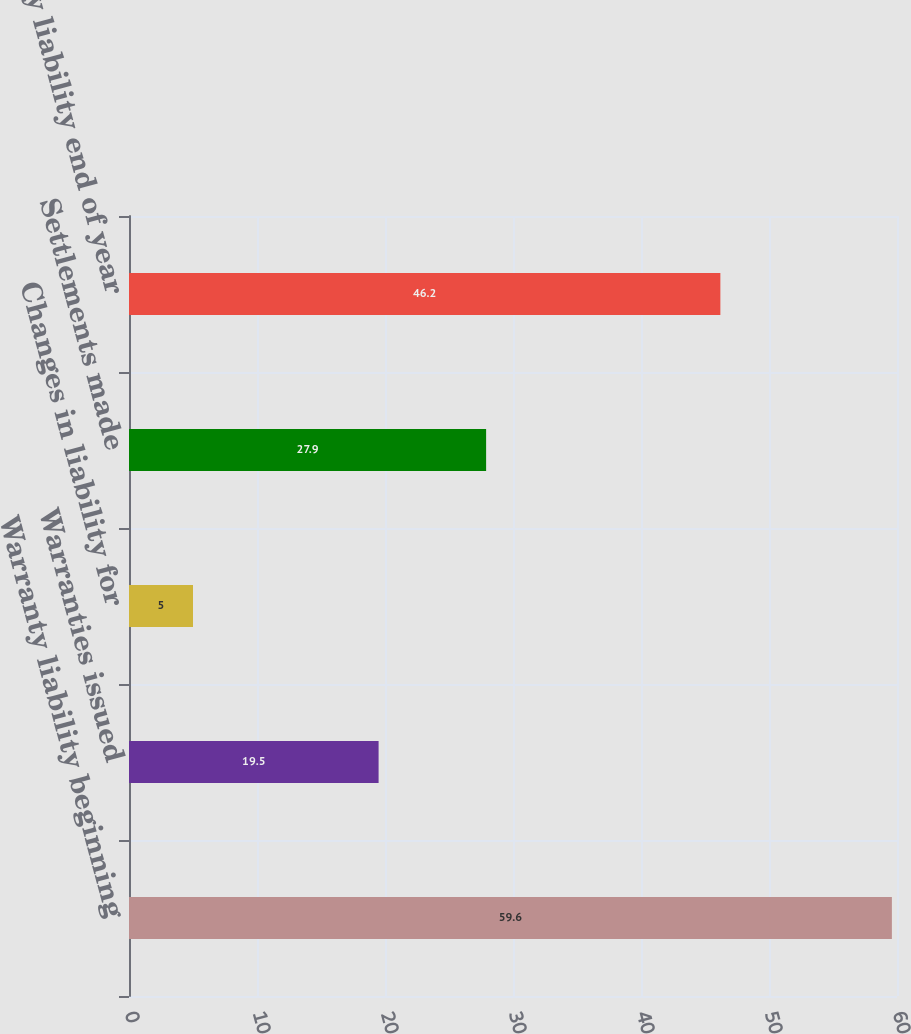Convert chart. <chart><loc_0><loc_0><loc_500><loc_500><bar_chart><fcel>Warranty liability beginning<fcel>Warranties issued<fcel>Changes in liability for<fcel>Settlements made<fcel>Warranty liability end of year<nl><fcel>59.6<fcel>19.5<fcel>5<fcel>27.9<fcel>46.2<nl></chart> 